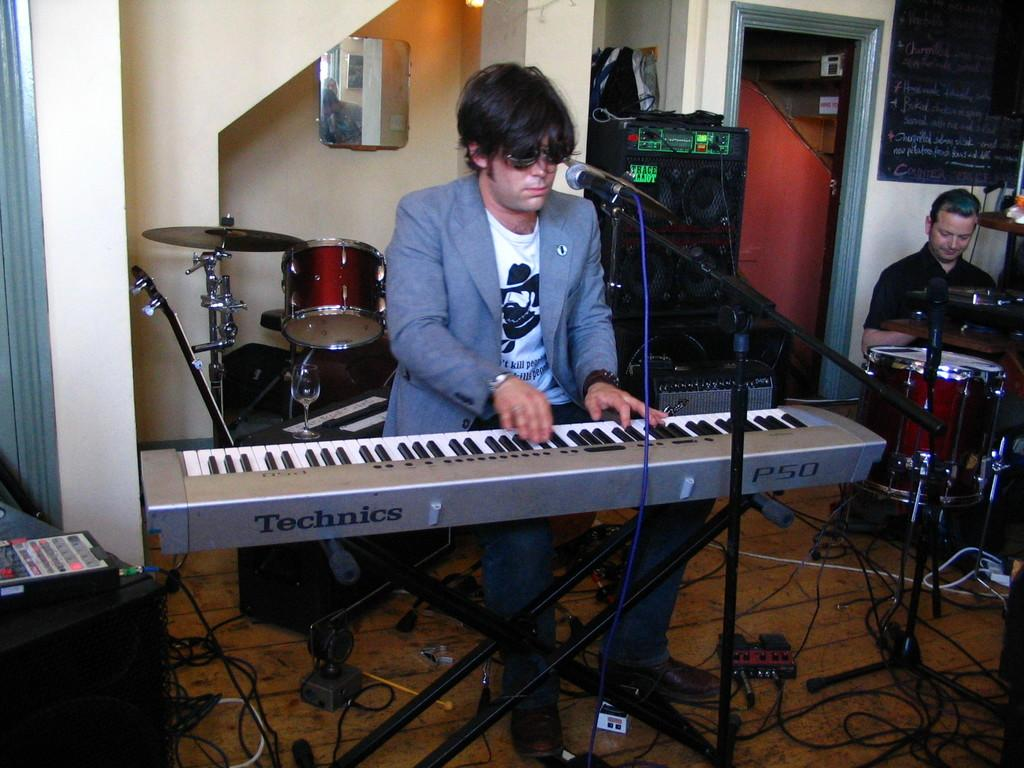What objects can be seen in the image related to music? There are musical instruments in the image. Can you describe the person's position in the image? There is a person sitting on a chair in the image. What type of background is visible in the image? There is a wall in the image. How many bells are hanging on the wall in the image? There are no bells visible in the image; only musical instruments, a person sitting on a chair, and a wall are present. Does the existence of the person in the image prove the existence of life on other planets? The presence of a person in the image does not provide any information about the existence of life on other planets. 